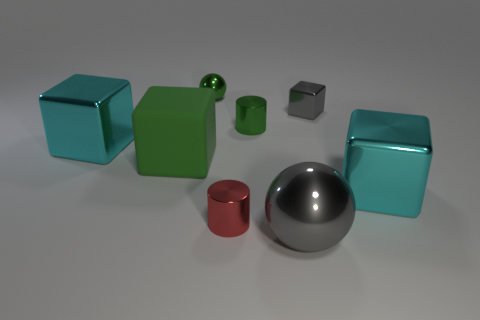What material is the cyan cube that is to the right of the cyan cube behind the large cyan metallic object on the right side of the small metal sphere?
Make the answer very short. Metal. The small object that is the same color as the tiny ball is what shape?
Offer a very short reply. Cylinder. Is the number of small metal cubes in front of the small ball greater than the number of small green things that are in front of the gray cube?
Provide a short and direct response. No. There is a red cylinder that is made of the same material as the small green ball; what size is it?
Provide a succinct answer. Small. How many big metal cubes are right of the cyan metallic object that is to the left of the small green metal cylinder?
Your answer should be very brief. 1. Are there any tiny gray metal things that have the same shape as the tiny red metallic object?
Offer a very short reply. No. What is the color of the large metal cube that is on the right side of the tiny metal cylinder that is behind the big matte block?
Ensure brevity in your answer.  Cyan. Is the number of large gray metallic objects greater than the number of green things?
Make the answer very short. No. What number of other rubber objects have the same size as the red object?
Offer a very short reply. 0. Is the small red cylinder made of the same material as the gray object that is in front of the small green shiny cylinder?
Provide a short and direct response. Yes. 